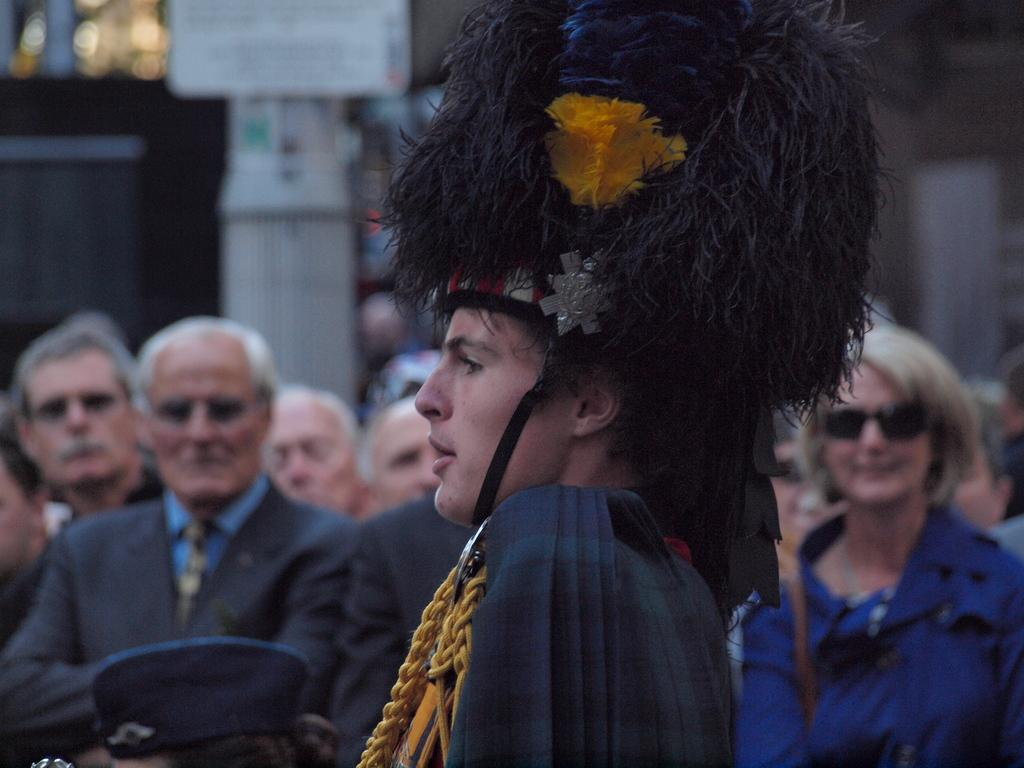What is notable about the appearance of the person in the image? The person in the image is wearing a wig. How many people are visible in the image? There is a group of persons visible in the image. What can be seen in the background of the image? There is a beam in the image. What type of nut is being used as a veil in the image? There is no nut or veil present in the image. What kind of operation is being performed on the person in the image? There is no operation being performed on the person in the image; they are simply wearing a wig. 